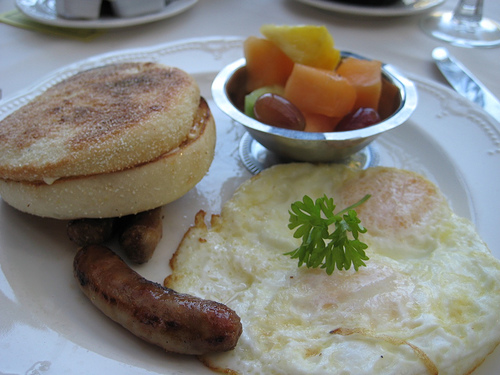<image>What kind of seeds are on the crust of the bread? I don't know what kind of seeds are on the crust of the bread. It could be none, poppy, fennel or sesame seeds. What kind of seeds are on the crust of the bread? It is unanswerable what kind of seeds are on the crust of the bread. 